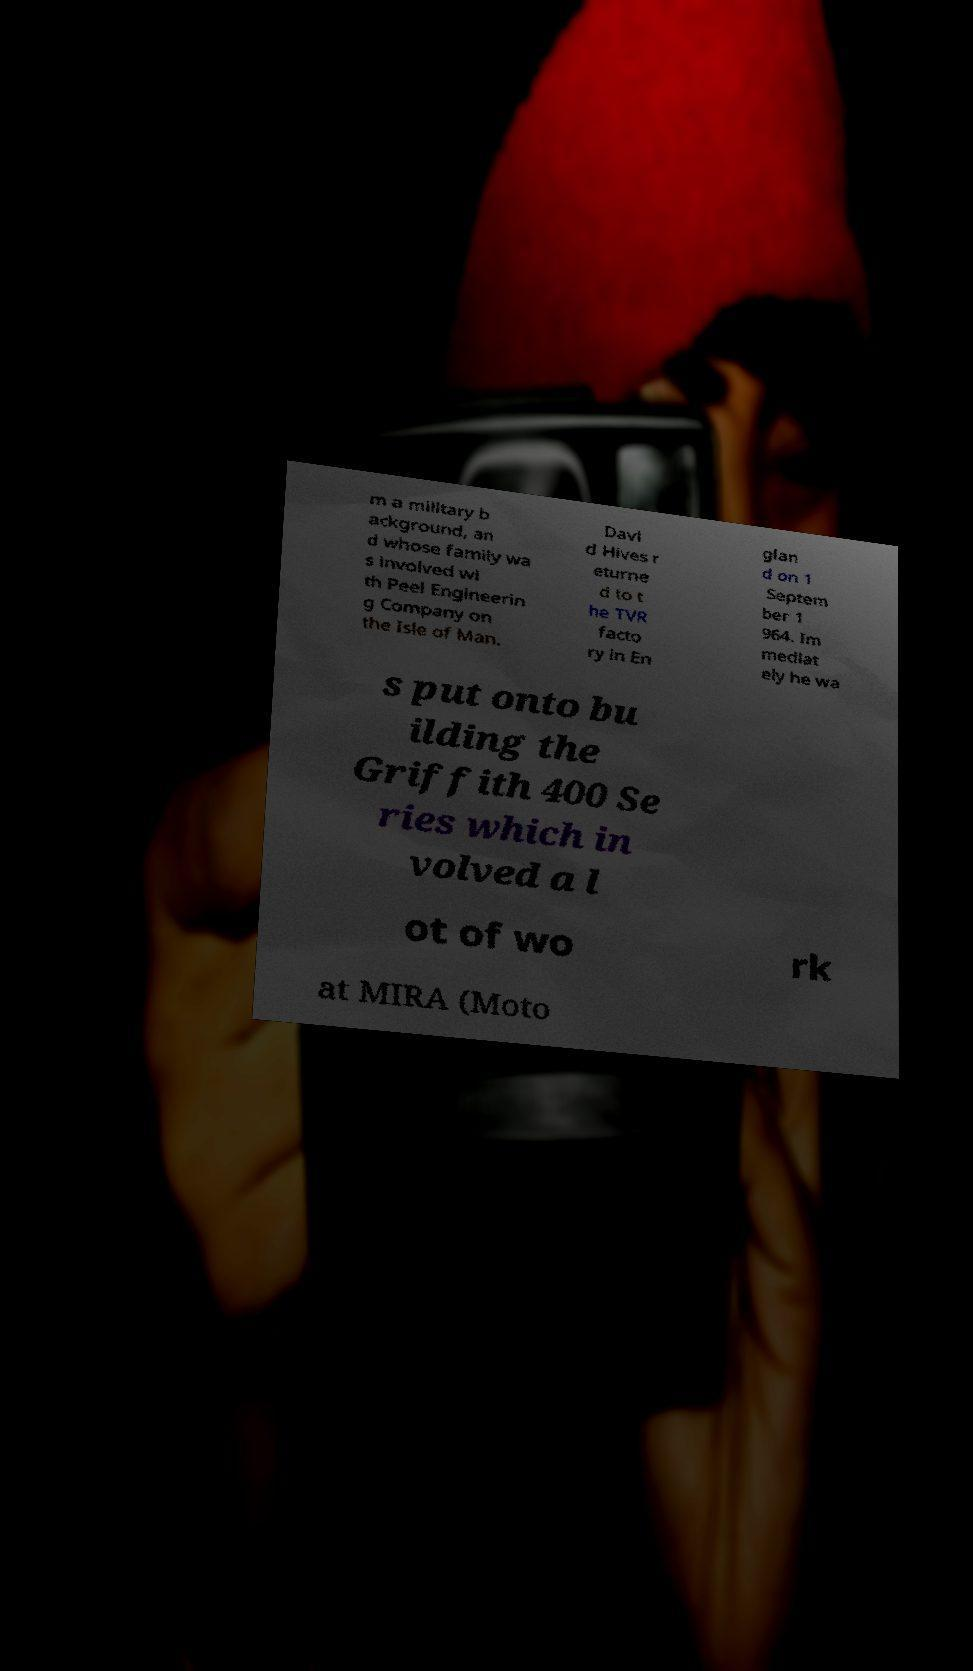I need the written content from this picture converted into text. Can you do that? m a military b ackground, an d whose family wa s involved wi th Peel Engineerin g Company on the Isle of Man. Davi d Hives r eturne d to t he TVR facto ry in En glan d on 1 Septem ber 1 964. Im mediat ely he wa s put onto bu ilding the Griffith 400 Se ries which in volved a l ot of wo rk at MIRA (Moto 